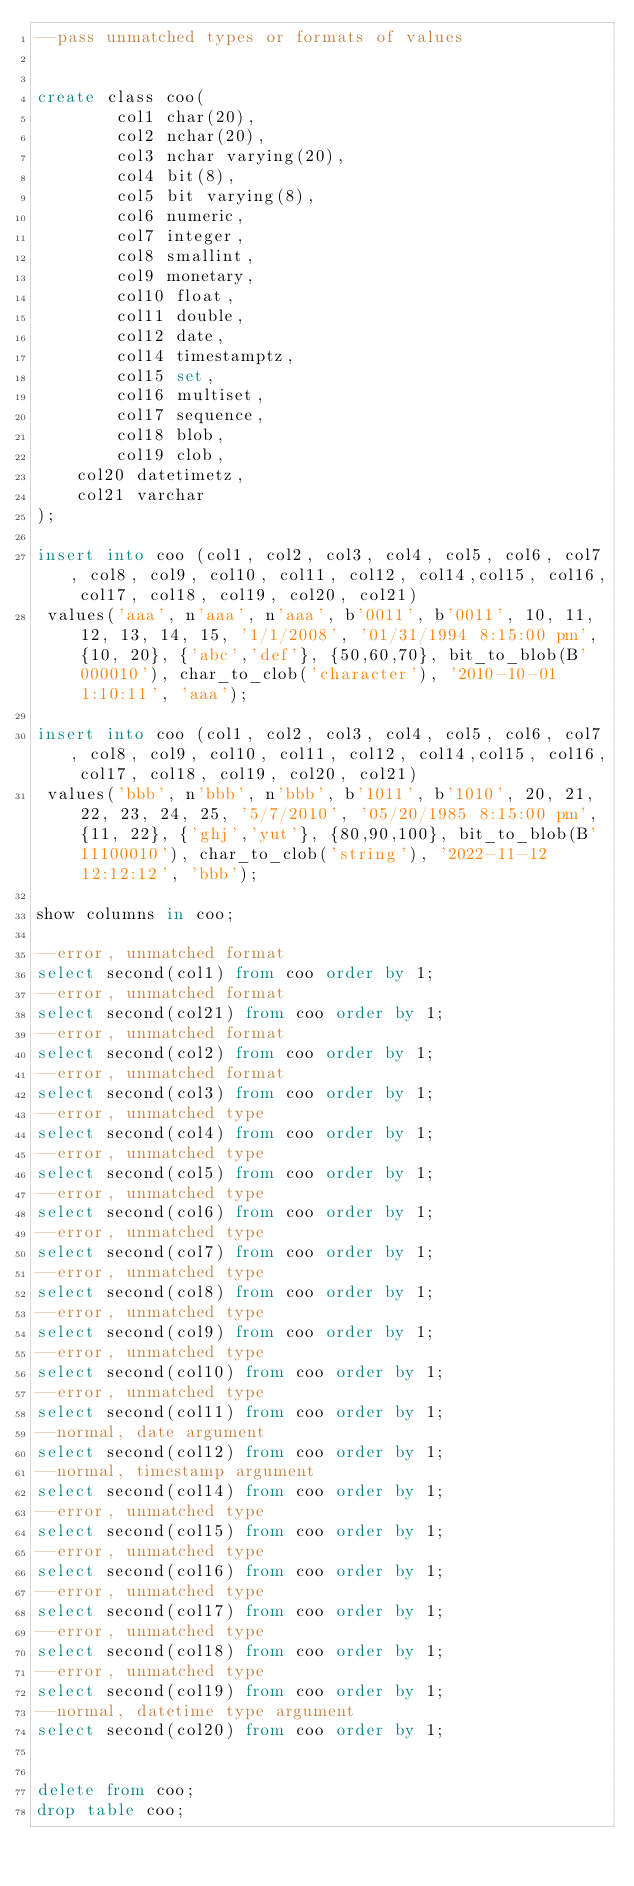<code> <loc_0><loc_0><loc_500><loc_500><_SQL_>--pass unmatched types or formats of values


create class coo(
        col1 char(20),
        col2 nchar(20),
        col3 nchar varying(20),
        col4 bit(8),
        col5 bit varying(8),
        col6 numeric,
        col7 integer,
        col8 smallint,
        col9 monetary,
        col10 float,
        col11 double,
        col12 date,
        col14 timestamptz,
        col15 set,
        col16 multiset,
        col17 sequence,
        col18 blob,
        col19 clob,
		col20 datetimetz,
		col21 varchar
);

insert into coo (col1, col2, col3, col4, col5, col6, col7, col8, col9, col10, col11, col12, col14,col15, col16, col17, col18, col19, col20, col21)
 values('aaa', n'aaa', n'aaa', b'0011', b'0011', 10, 11, 12, 13, 14, 15, '1/1/2008', '01/31/1994 8:15:00 pm', {10, 20}, {'abc','def'}, {50,60,70}, bit_to_blob(B'000010'), char_to_clob('character'), '2010-10-01 1:10:11', 'aaa');

insert into coo (col1, col2, col3, col4, col5, col6, col7, col8, col9, col10, col11, col12, col14,col15, col16, col17, col18, col19, col20, col21)
 values('bbb', n'bbb', n'bbb', b'1011', b'1010', 20, 21, 22, 23, 24, 25, '5/7/2010', '05/20/1985 8:15:00 pm', {11, 22}, {'ghj','yut'}, {80,90,100}, bit_to_blob(B'11100010'), char_to_clob('string'), '2022-11-12 12:12:12', 'bbb');

show columns in coo;

--error, unmatched format
select second(col1) from coo order by 1;
--error, unmatched format
select second(col21) from coo order by 1;
--error, unmatched format
select second(col2) from coo order by 1;
--error, unmatched format
select second(col3) from coo order by 1;
--error, unmatched type
select second(col4) from coo order by 1;
--error, unmatched type
select second(col5) from coo order by 1;
--error, unmatched type
select second(col6) from coo order by 1;
--error, unmatched type
select second(col7) from coo order by 1;
--error, unmatched type
select second(col8) from coo order by 1;
--error, unmatched type
select second(col9) from coo order by 1;
--error, unmatched type
select second(col10) from coo order by 1;
--error, unmatched type
select second(col11) from coo order by 1;
--normal, date argument
select second(col12) from coo order by 1;
--normal, timestamp argument
select second(col14) from coo order by 1;
--error, unmatched type
select second(col15) from coo order by 1;
--error, unmatched type
select second(col16) from coo order by 1;
--error, unmatched type
select second(col17) from coo order by 1;
--error, unmatched type
select second(col18) from coo order by 1;
--error, unmatched type
select second(col19) from coo order by 1;
--normal, datetime type argument
select second(col20) from coo order by 1;


delete from coo;
drop table coo;


</code> 